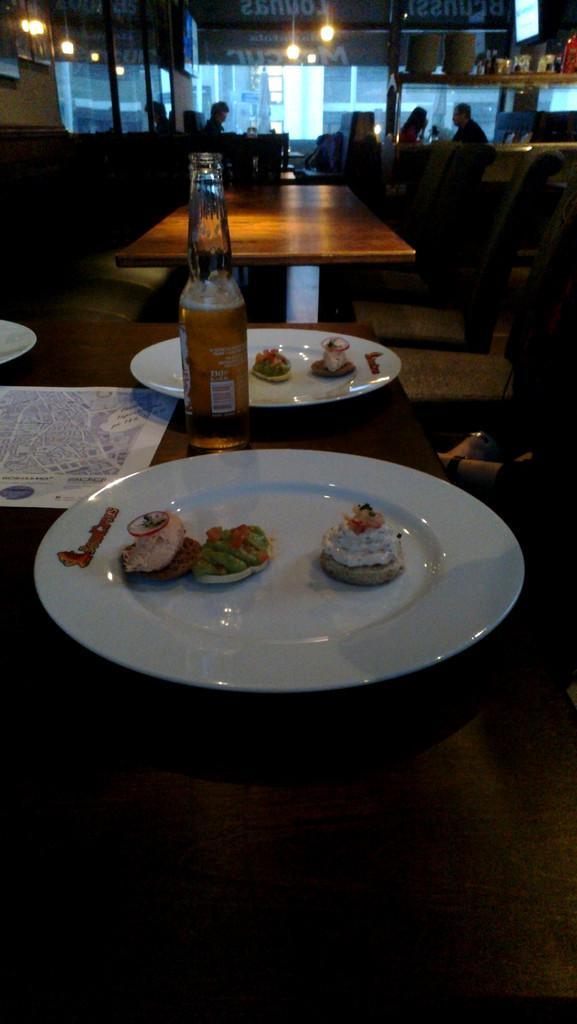Can you describe this image briefly? This picture is taken in a restaurant. In front of picture, we see a table on which plate containing food and alcohol bottle are placed on the table. Behind that, we see many people standing and on top of picture, we see lights. 